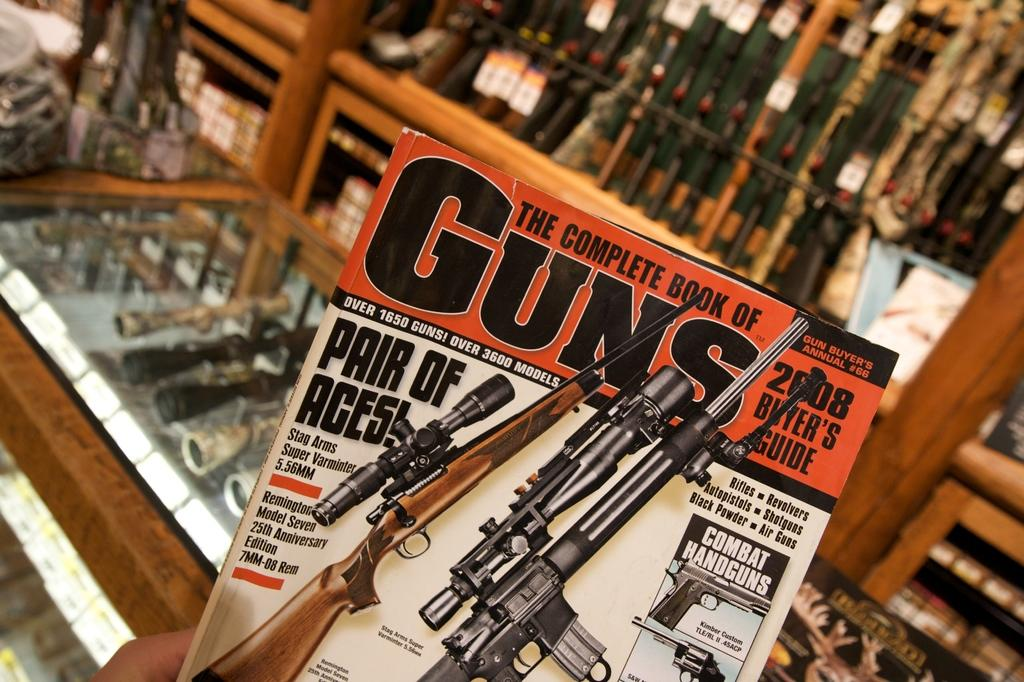Provide a one-sentence caption for the provided image. A magazine called GUNS with rifles on the cover. 